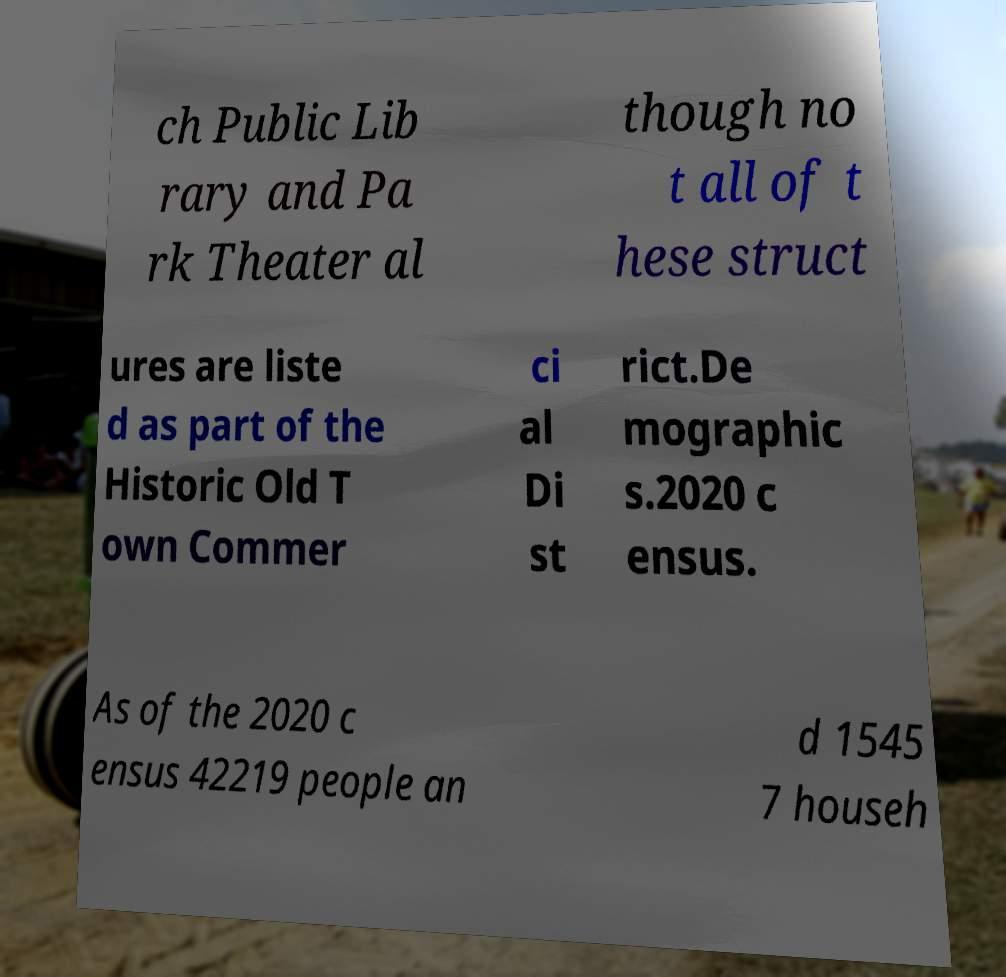Please identify and transcribe the text found in this image. ch Public Lib rary and Pa rk Theater al though no t all of t hese struct ures are liste d as part of the Historic Old T own Commer ci al Di st rict.De mographic s.2020 c ensus. As of the 2020 c ensus 42219 people an d 1545 7 househ 